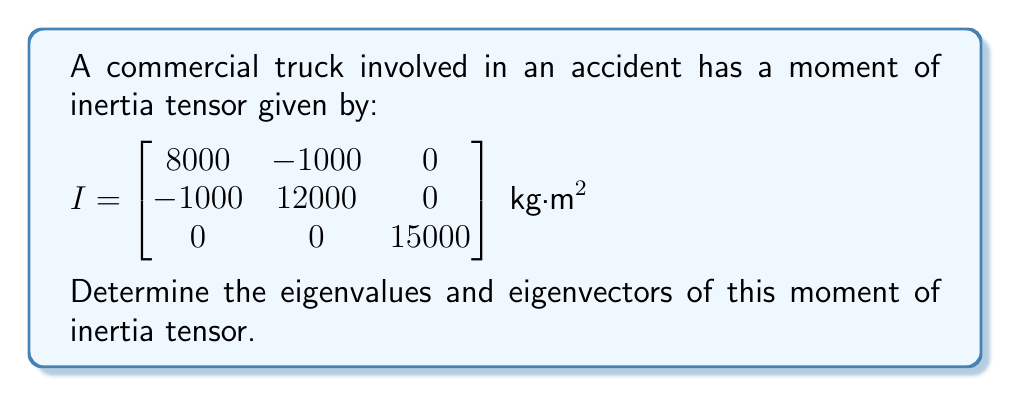Show me your answer to this math problem. To find the eigenvalues and eigenvectors of the moment of inertia tensor, we follow these steps:

1) First, we find the eigenvalues by solving the characteristic equation:
   $$\det(I - \lambda I) = 0$$
   where $I$ is the identity matrix and $\lambda$ are the eigenvalues.

2) Expanding the determinant:
   $$\begin{vmatrix}
   8000-\lambda & -1000 & 0 \\
   -1000 & 12000-\lambda & 0 \\
   0 & 0 & 15000-\lambda
   \end{vmatrix} = 0$$

3) This gives us:
   $$(8000-\lambda)(12000-\lambda)(15000-\lambda) - (-1000)^2(15000-\lambda) = 0$$

4) Simplifying:
   $$(\lambda-7000)(\lambda-13000)(15000-\lambda) = 0$$

5) The eigenvalues are the roots of this equation:
   $\lambda_1 = 7000$, $\lambda_2 = 13000$, $\lambda_3 = 15000$

6) For each eigenvalue, we find the corresponding eigenvector $\mathbf{v}$ by solving:
   $$(I - \lambda I)\mathbf{v} = 0$$

7) For $\lambda_1 = 7000$:
   $$\begin{bmatrix}
   1000 & -1000 & 0 \\
   -1000 & 5000 & 0 \\
   0 & 0 & 8000
   \end{bmatrix}\begin{bmatrix}
   v_1 \\
   v_2 \\
   v_3
   \end{bmatrix} = \begin{bmatrix}
   0 \\
   0 \\
   0
   \end{bmatrix}$$

   Solving this gives us: $\mathbf{v}_1 = (1, 1, 0)$

8) For $\lambda_2 = 13000$:
   $$\begin{bmatrix}
   -5000 & -1000 & 0 \\
   -1000 & -1000 & 0 \\
   0 & 0 & 2000
   \end{bmatrix}\begin{bmatrix}
   v_1 \\
   v_2 \\
   v_3
   \end{bmatrix} = \begin{bmatrix}
   0 \\
   0 \\
   0
   \end{bmatrix}$$

   Solving this gives us: $\mathbf{v}_2 = (-1, 5, 0)$

9) For $\lambda_3 = 15000$:
   $$\begin{bmatrix}
   -7000 & -1000 & 0 \\
   -1000 & -3000 & 0 \\
   0 & 0 & 0
   \end{bmatrix}\begin{bmatrix}
   v_1 \\
   v_2 \\
   v_3
   \end{bmatrix} = \begin{bmatrix}
   0 \\
   0 \\
   0
   \end{bmatrix}$$

   Solving this gives us: $\mathbf{v}_3 = (0, 0, 1)$
Answer: Eigenvalues: $\lambda_1 = 7000$, $\lambda_2 = 13000$, $\lambda_3 = 15000$ kg·m²
Eigenvectors: $\mathbf{v}_1 = (1, 1, 0)$, $\mathbf{v}_2 = (-1, 5, 0)$, $\mathbf{v}_3 = (0, 0, 1)$ 